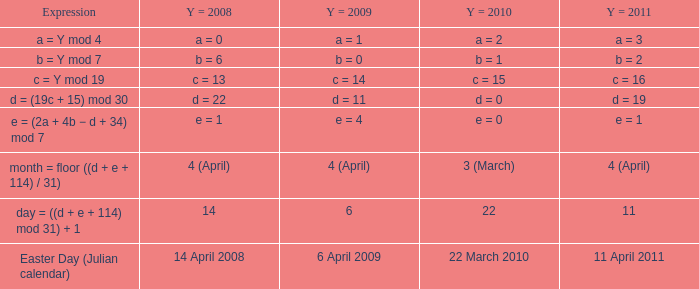Parse the table in full. {'header': ['Expression', 'Y = 2008', 'Y = 2009', 'Y = 2010', 'Y = 2011'], 'rows': [['a = Y mod 4', 'a = 0', 'a = 1', 'a = 2', 'a = 3'], ['b = Y mod 7', 'b = 6', 'b = 0', 'b = 1', 'b = 2'], ['c = Y mod 19', 'c = 13', 'c = 14', 'c = 15', 'c = 16'], ['d = (19c + 15) mod 30', 'd = 22', 'd = 11', 'd = 0', 'd = 19'], ['e = (2a + 4b − d + 34) mod 7', 'e = 1', 'e = 4', 'e = 0', 'e = 1'], ['month = floor ((d + e + 114) / 31)', '4 (April)', '4 (April)', '3 (March)', '4 (April)'], ['day = ((d + e + 114) mod 31) + 1', '14', '6', '22', '11'], ['Easter Day (Julian calendar)', '14 April 2008', '6 April 2009', '22 March 2010', '11 April 2011']]} What is the y = 2008 when the expression is easter day (julian calendar)? 14 April 2008. 